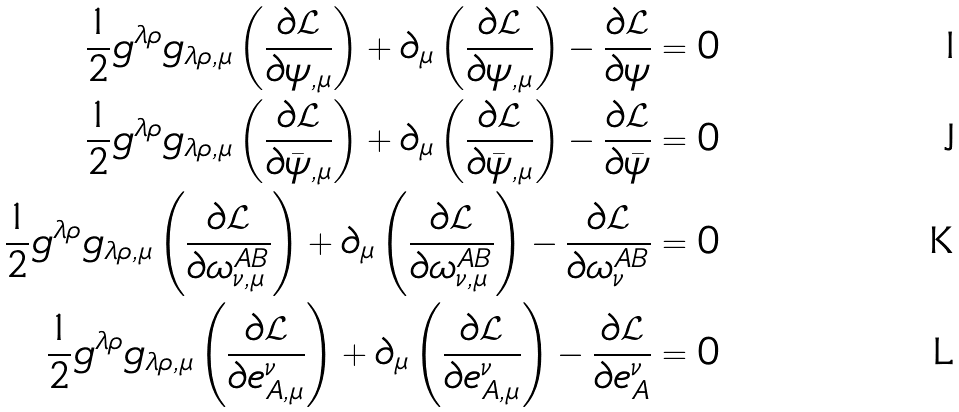<formula> <loc_0><loc_0><loc_500><loc_500>\frac { 1 } { 2 } g ^ { \lambda \rho } g _ { \lambda \rho , \mu } \left ( \frac { \partial \mathcal { L } } { \partial \psi _ { , \mu } } \right ) + \partial _ { \mu } \left ( \frac { \partial \mathcal { L } } { \partial \psi _ { , \mu } } \right ) - \frac { \partial \mathcal { L } } { \partial \psi } & = 0 \\ \frac { 1 } { 2 } g ^ { \lambda \rho } g _ { \lambda \rho , \mu } \left ( \frac { \partial \mathcal { L } } { \partial \bar { \psi } _ { , \mu } } \right ) + \partial _ { \mu } \left ( \frac { \partial \mathcal { L } } { \partial \bar { \psi } _ { , \mu } } \right ) - \frac { \partial \mathcal { L } } { \partial \bar { \psi } } & = 0 \\ \frac { 1 } { 2 } g ^ { \lambda \rho } g _ { \lambda \rho , \mu } \left ( \frac { \partial \mathcal { L } } { \partial \omega ^ { A B } _ { \nu , \mu } } \right ) + \partial _ { \mu } \left ( \frac { \partial \mathcal { L } } { \partial \omega ^ { A B } _ { \nu , \mu } } \right ) - \frac { \partial \mathcal { L } } { \partial \omega ^ { A B } _ { \nu } } & = 0 \\ \frac { 1 } { 2 } g ^ { \lambda \rho } g _ { \lambda \rho , \mu } \left ( \frac { \partial \mathcal { L } } { \partial e ^ { \nu } _ { A , \mu } } \right ) + \partial _ { \mu } \left ( \frac { \partial \mathcal { L } } { \partial e ^ { \nu } _ { A , \mu } } \right ) - \frac { \partial \mathcal { L } } { \partial e ^ { \nu } _ { A } } & = 0</formula> 